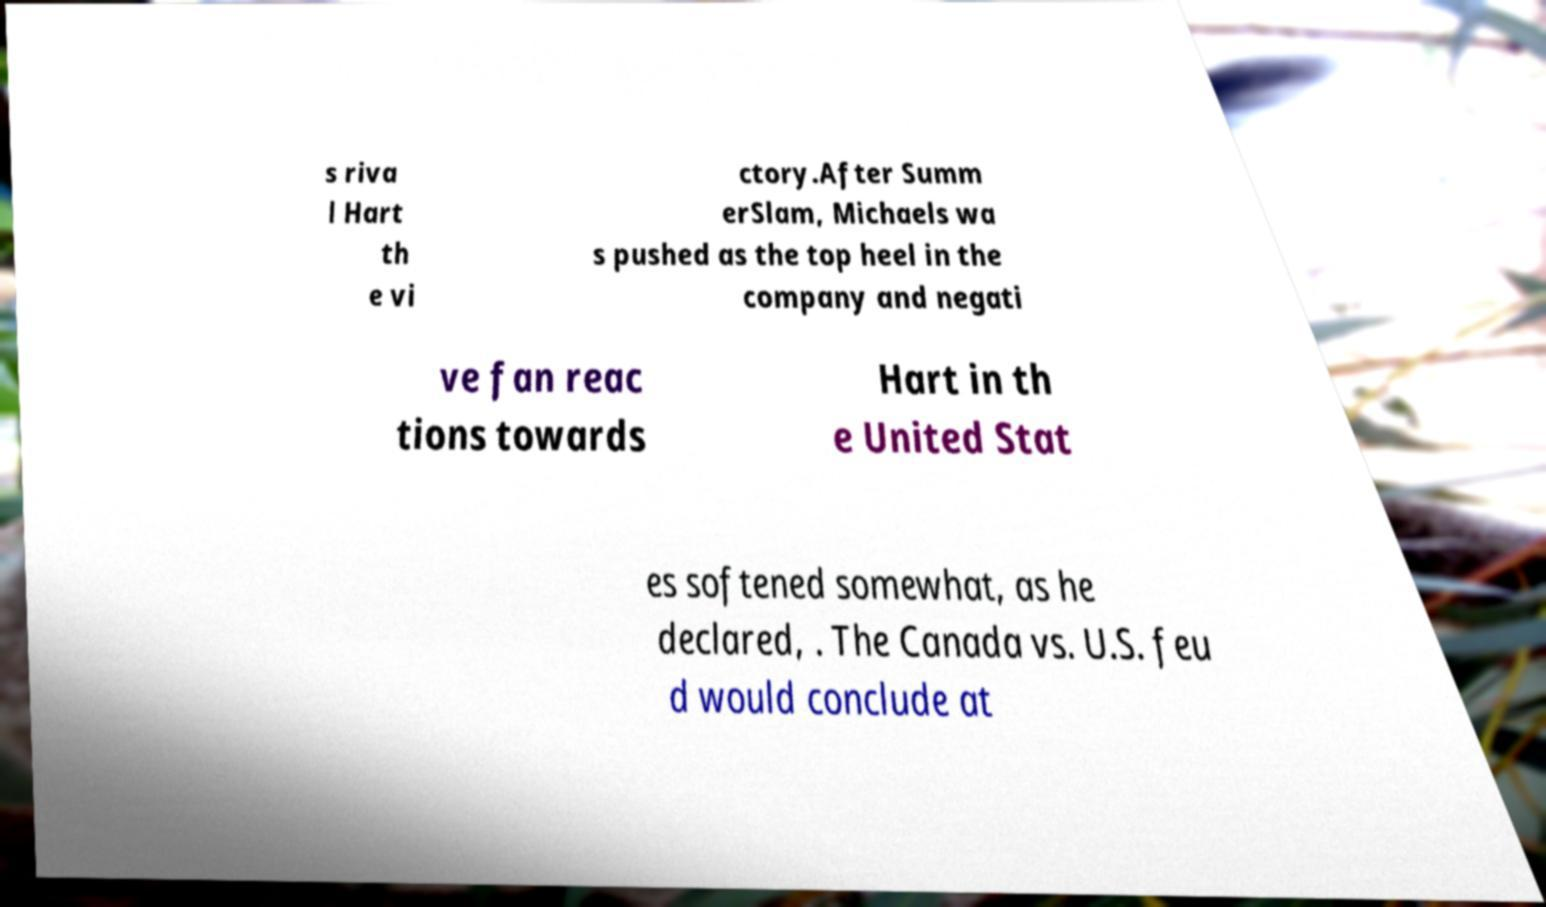Could you assist in decoding the text presented in this image and type it out clearly? s riva l Hart th e vi ctory.After Summ erSlam, Michaels wa s pushed as the top heel in the company and negati ve fan reac tions towards Hart in th e United Stat es softened somewhat, as he declared, . The Canada vs. U.S. feu d would conclude at 